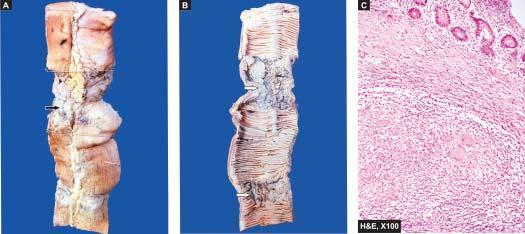does the deposits show characteristic transverse ulcers and two strictures?
Answer the question using a single word or phrase. No 